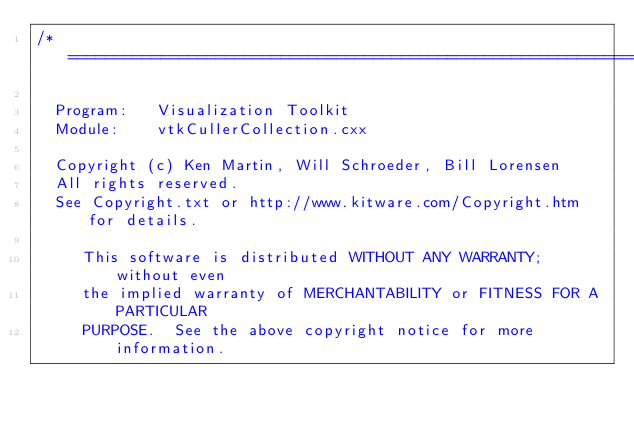Convert code to text. <code><loc_0><loc_0><loc_500><loc_500><_C++_>/*=========================================================================

  Program:   Visualization Toolkit
  Module:    vtkCullerCollection.cxx

  Copyright (c) Ken Martin, Will Schroeder, Bill Lorensen
  All rights reserved.
  See Copyright.txt or http://www.kitware.com/Copyright.htm for details.

     This software is distributed WITHOUT ANY WARRANTY; without even
     the implied warranty of MERCHANTABILITY or FITNESS FOR A PARTICULAR
     PURPOSE.  See the above copyright notice for more information.
</code> 